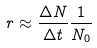<formula> <loc_0><loc_0><loc_500><loc_500>r \approx \frac { \Delta N } { \Delta t } \frac { 1 } { N _ { 0 } }</formula> 